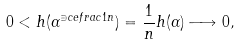Convert formula to latex. <formula><loc_0><loc_0><loc_500><loc_500>0 < h ( \alpha ^ { \ni c e f r a c { 1 } { n } } ) = \frac { 1 } { n } h ( \alpha ) \longrightarrow 0 ,</formula> 